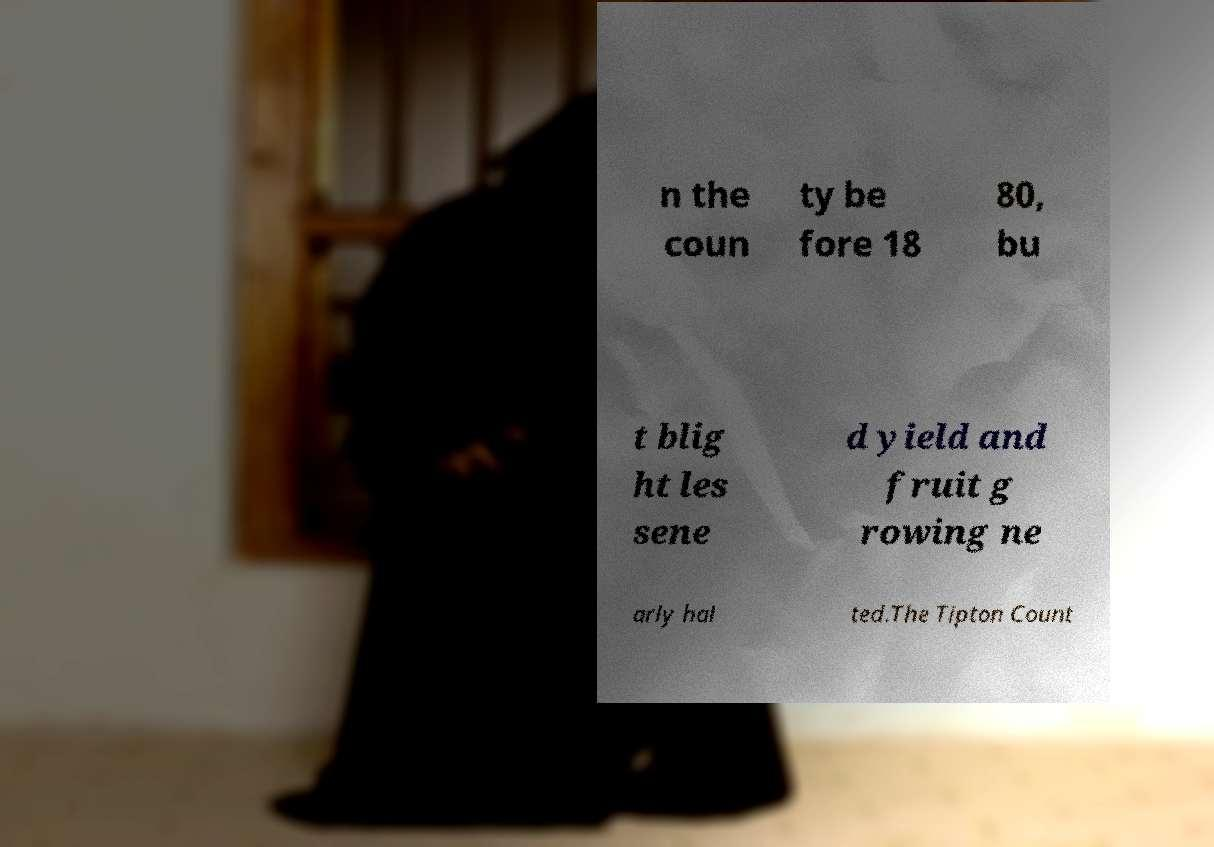Could you assist in decoding the text presented in this image and type it out clearly? n the coun ty be fore 18 80, bu t blig ht les sene d yield and fruit g rowing ne arly hal ted.The Tipton Count 